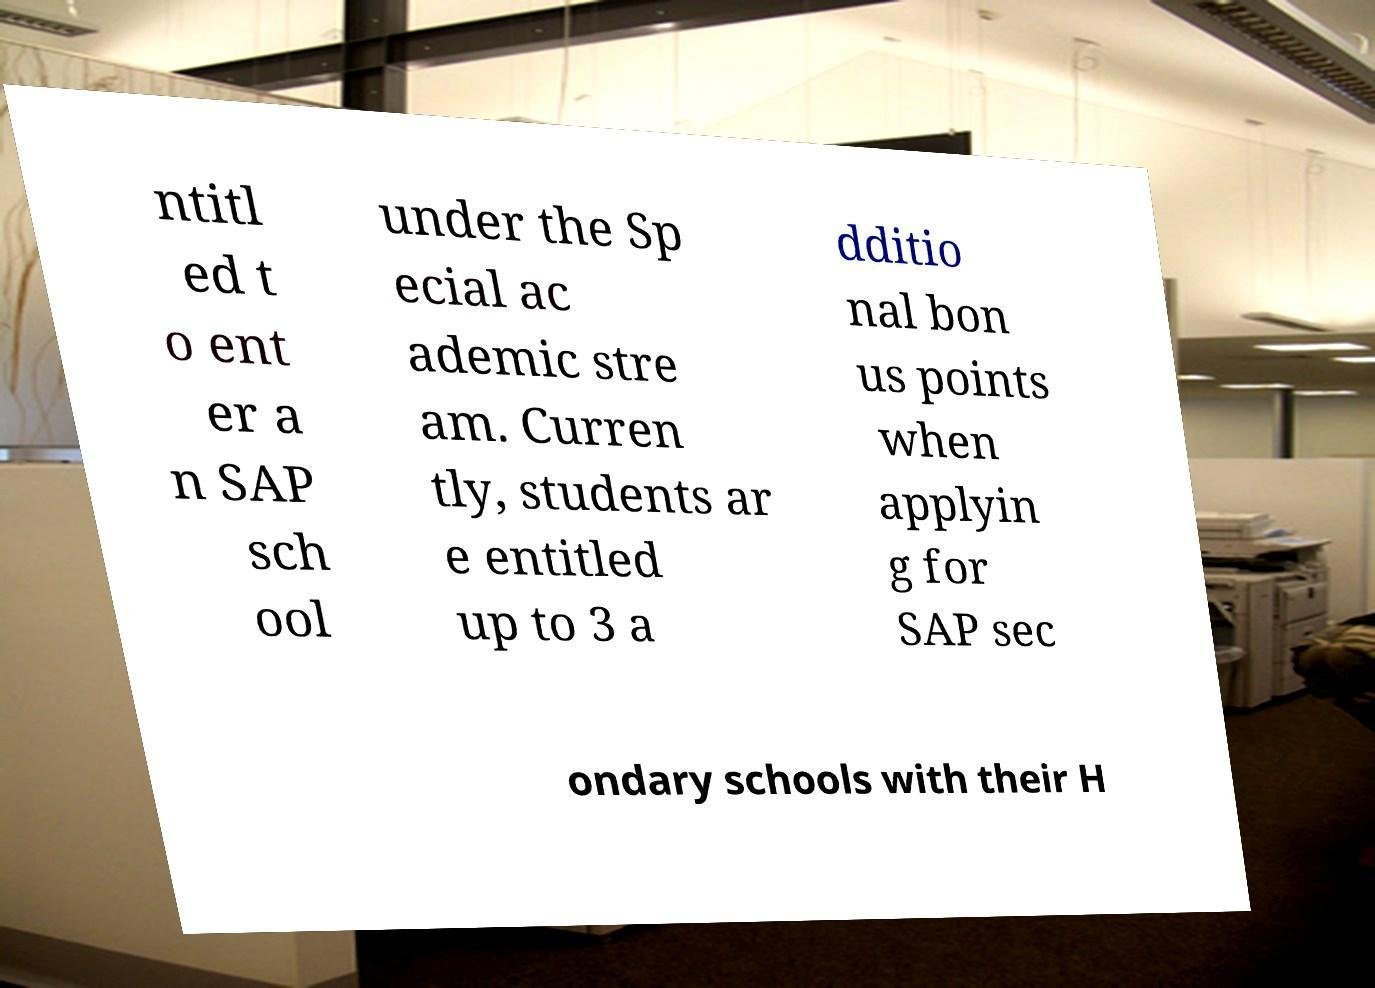Can you accurately transcribe the text from the provided image for me? ntitl ed t o ent er a n SAP sch ool under the Sp ecial ac ademic stre am. Curren tly, students ar e entitled up to 3 a dditio nal bon us points when applyin g for SAP sec ondary schools with their H 